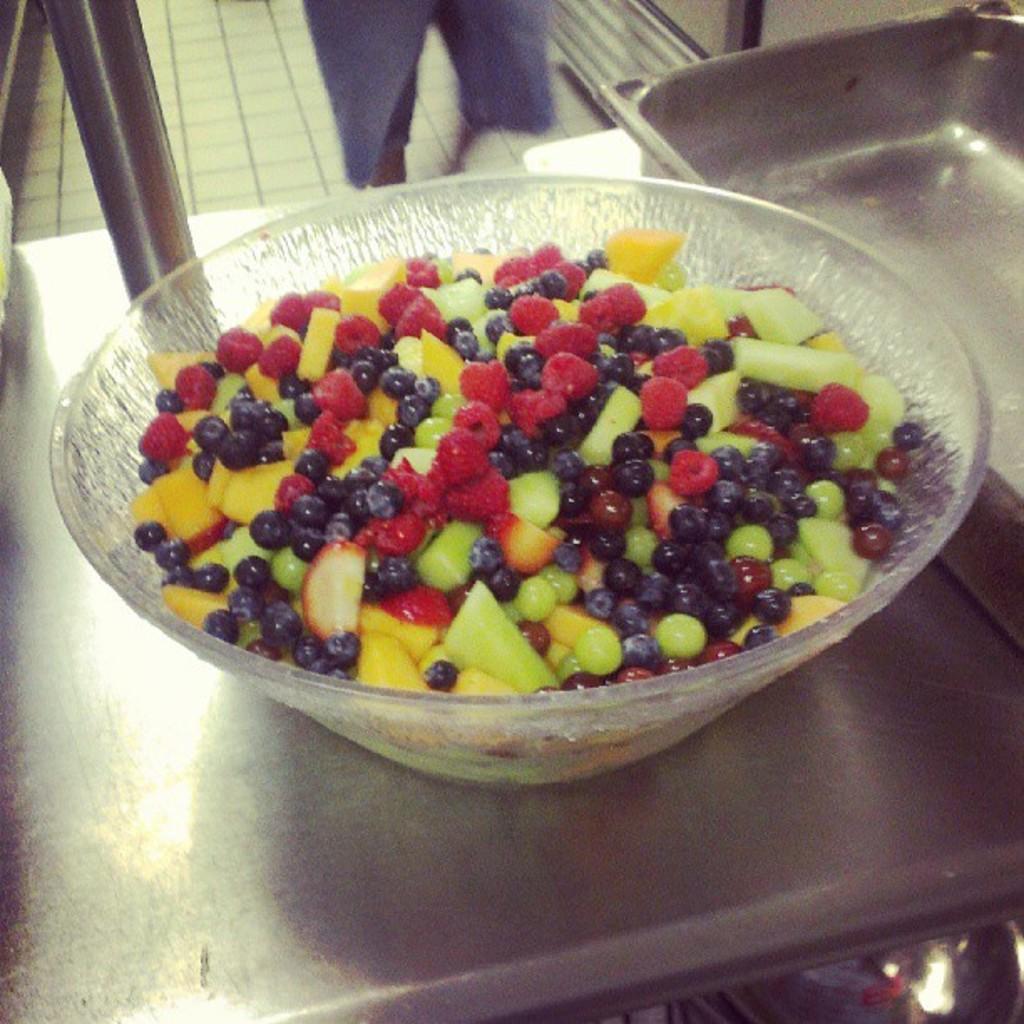Please provide a concise description of this image. In this image there is an object on the right corner. There are fruits in the bowl. And there is a table like object at the bottom. There is a person, there is a floor in the background. 